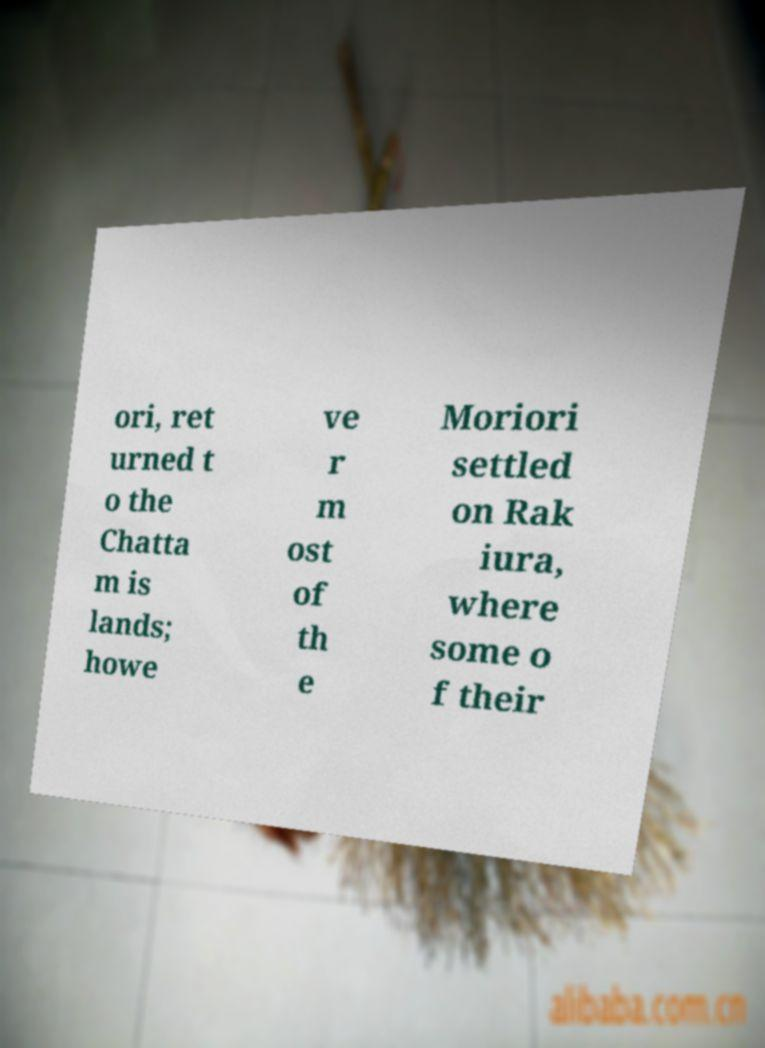Could you extract and type out the text from this image? ori, ret urned t o the Chatta m is lands; howe ve r m ost of th e Moriori settled on Rak iura, where some o f their 